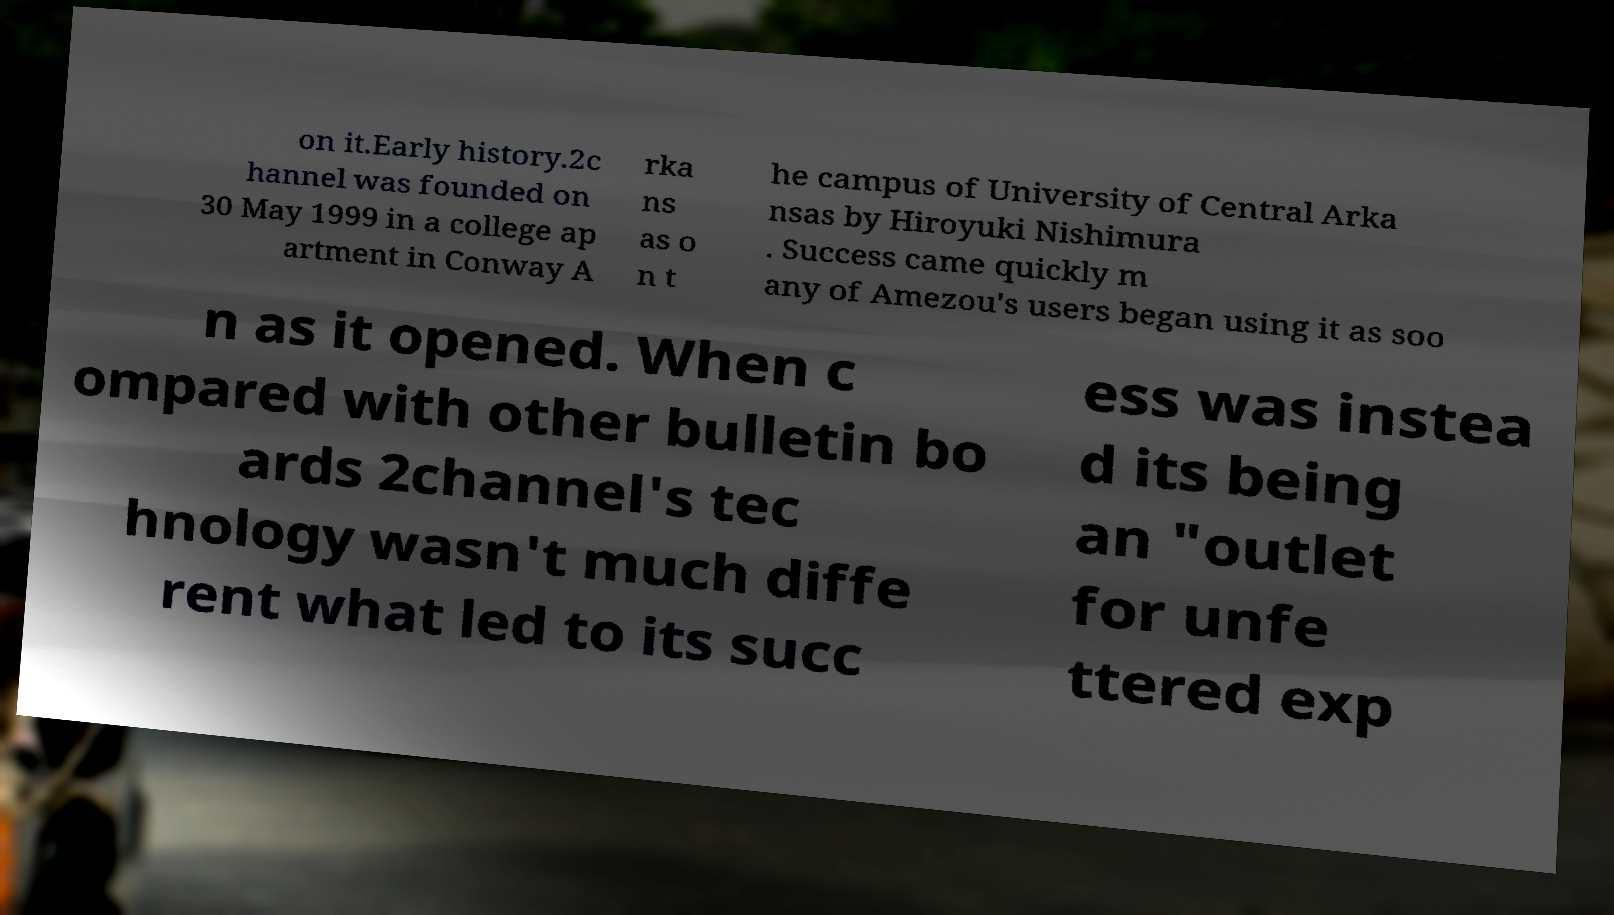Can you read and provide the text displayed in the image?This photo seems to have some interesting text. Can you extract and type it out for me? on it.Early history.2c hannel was founded on 30 May 1999 in a college ap artment in Conway A rka ns as o n t he campus of University of Central Arka nsas by Hiroyuki Nishimura . Success came quickly m any of Amezou's users began using it as soo n as it opened. When c ompared with other bulletin bo ards 2channel's tec hnology wasn't much diffe rent what led to its succ ess was instea d its being an "outlet for unfe ttered exp 